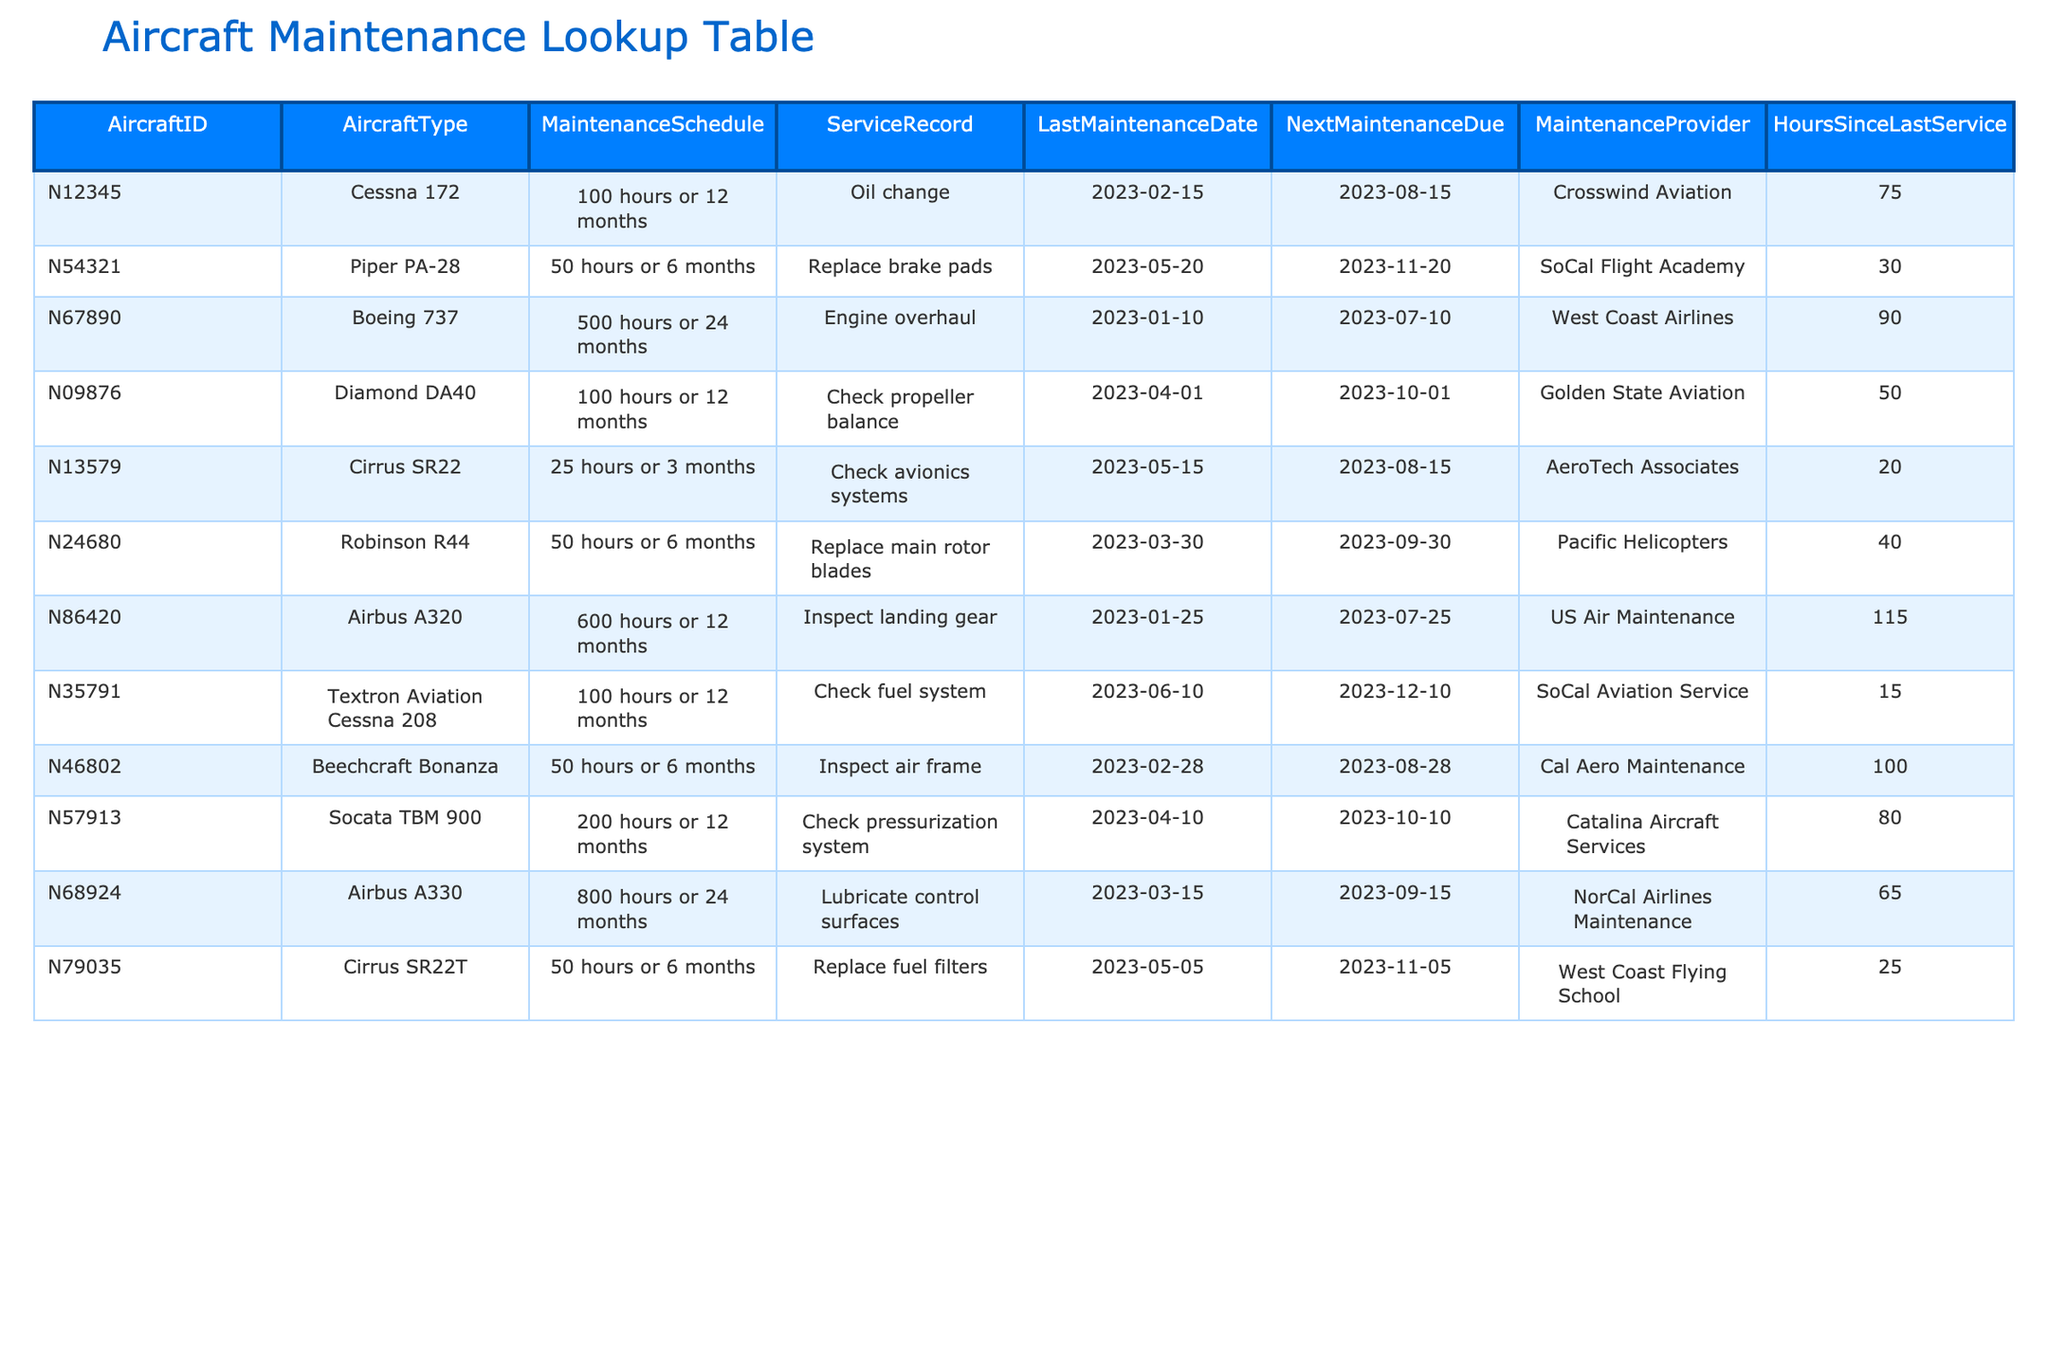What maintenance is due next for Aircraft ID N54321? The table shows that the next maintenance due for Aircraft ID N54321, a Piper PA-28, is scheduled for 2023-11-20.
Answer: 2023-11-20 How many hours since the last service for the Cessna 172? The 'Hours Since Last Service' column for the Cessna 172 (Aircraft ID N12345) shows 75 hours.
Answer: 75 Which aircraft type requires an engine overhaul and is due next maintenance in July 2023? Reviewing the table, the Boeing 737 (Aircraft ID N67890) has the service record of an engine overhaul and its next maintenance is due on 2023-07-10.
Answer: Boeing 737 What is the average hours since last service for all aircraft in the table? Adding up the hours since last service for all the aircraft gives: 75 + 30 + 90 + 50 + 20 + 40 + 115 + 15 + 100 + 80 + 65 + 25 =  720 hours. Dividing by the total number of aircraft (12), the average is 720 / 12 = 60 hours.
Answer: 60 Is the next maintenance due for the Airbus A330 after or before the next maintenance due for the Cirrus SR22T? The next maintenance for the Airbus A330 (2023-09-15) is before the Cirrus SR22T (2023-11-05). Thus, the statement is true.
Answer: Yes What is the service record for the Robinson R44? According to the table, the service record for the Robinson R44 (Aircraft ID N24680) is "Replace main rotor blades."
Answer: Replace main rotor blades How many types of aircraft are scheduled for maintenance in the month of November? Checking the list, the Piper PA-28 and the Cirrus SR22T are both due for maintenance in November (2023-11-20 and 2023-11-05, respectively). Therefore, there are two aircraft types.
Answer: 2 Which aircraft has the longest interval before its next maintenance? The Airbus A330 is due for maintenance after 800 hours or 24 months, which gives it the longest interval before its next maintenance (2023-09-15).
Answer: Airbus A330 